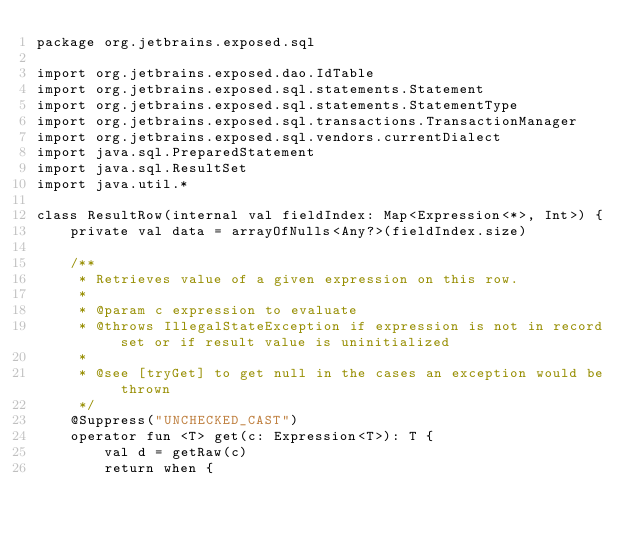Convert code to text. <code><loc_0><loc_0><loc_500><loc_500><_Kotlin_>package org.jetbrains.exposed.sql

import org.jetbrains.exposed.dao.IdTable
import org.jetbrains.exposed.sql.statements.Statement
import org.jetbrains.exposed.sql.statements.StatementType
import org.jetbrains.exposed.sql.transactions.TransactionManager
import org.jetbrains.exposed.sql.vendors.currentDialect
import java.sql.PreparedStatement
import java.sql.ResultSet
import java.util.*

class ResultRow(internal val fieldIndex: Map<Expression<*>, Int>) {
    private val data = arrayOfNulls<Any?>(fieldIndex.size)

    /**
     * Retrieves value of a given expression on this row.
     *
     * @param c expression to evaluate
     * @throws IllegalStateException if expression is not in record set or if result value is uninitialized
     *
     * @see [tryGet] to get null in the cases an exception would be thrown
     */
    @Suppress("UNCHECKED_CAST")
    operator fun <T> get(c: Expression<T>): T {
        val d = getRaw(c)
        return when {</code> 